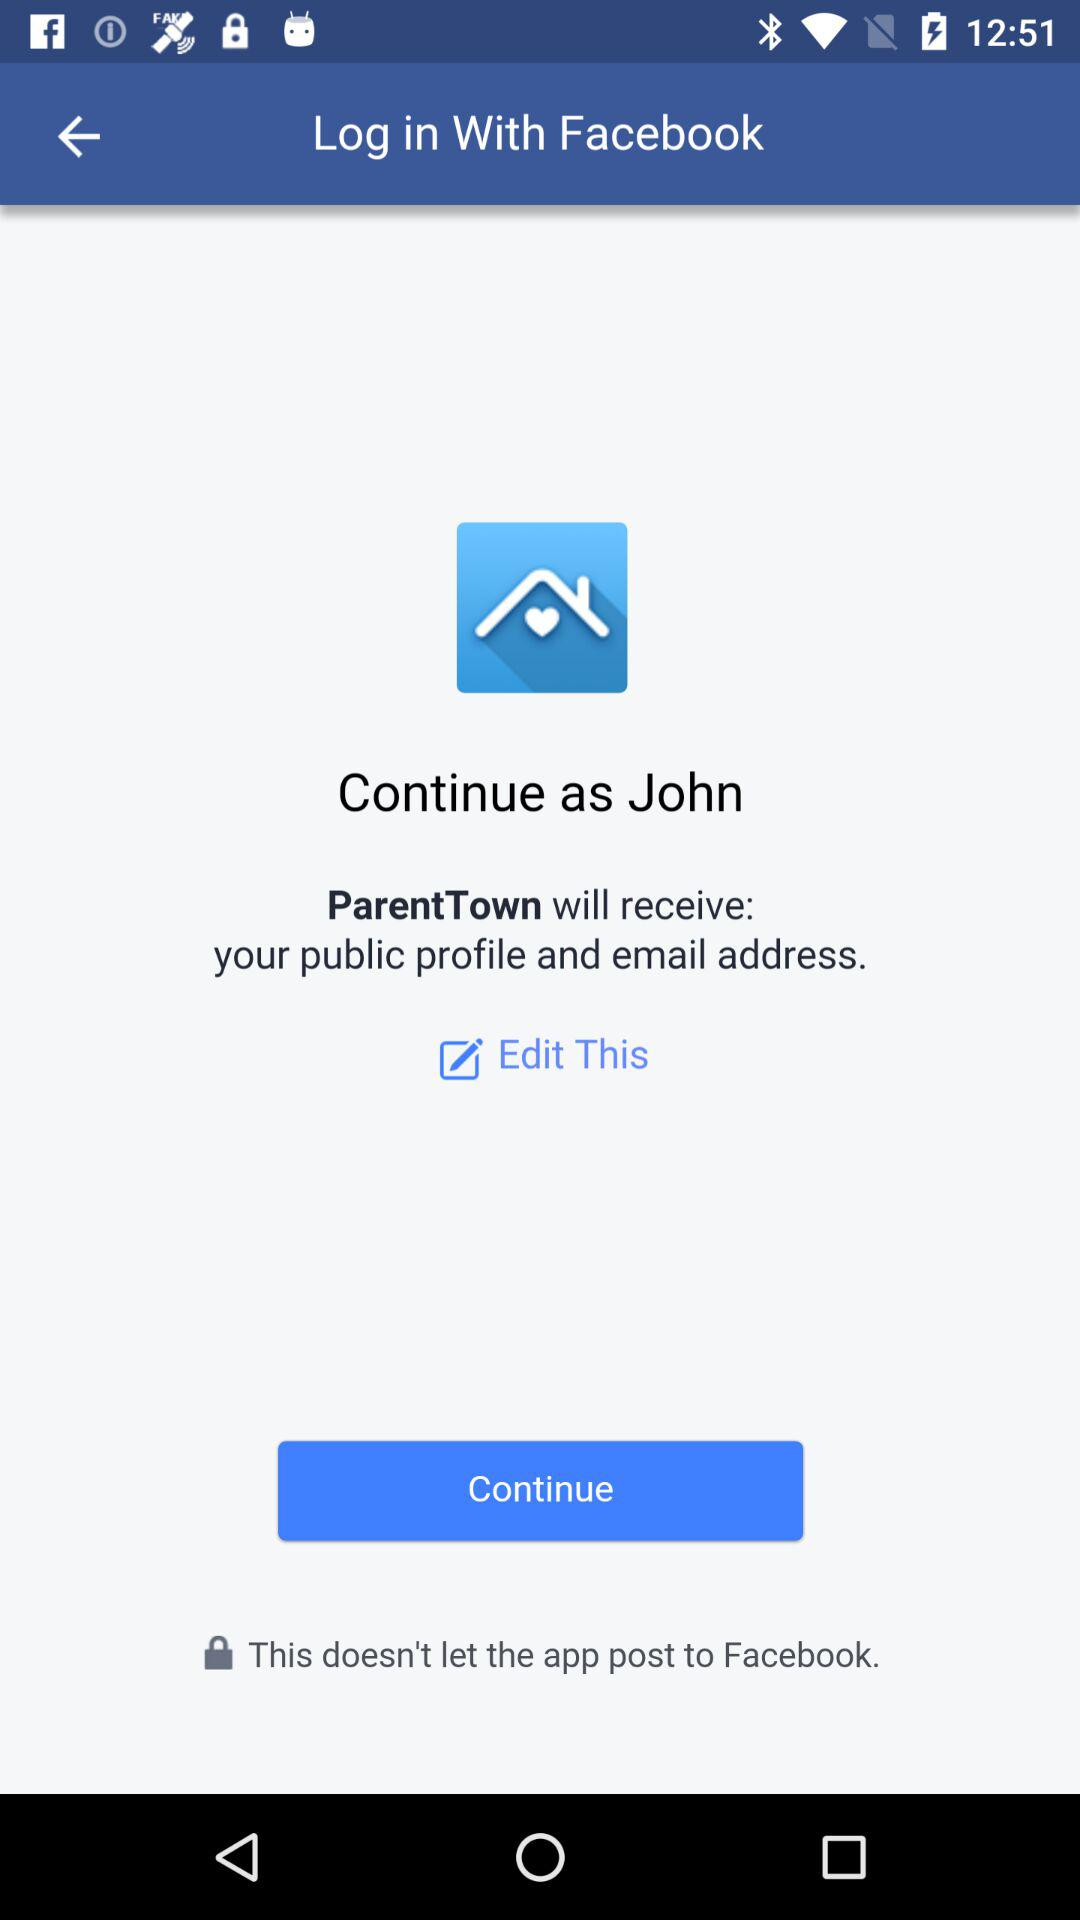What application will receive a public profile and an email address? The application is "ParentTown". 